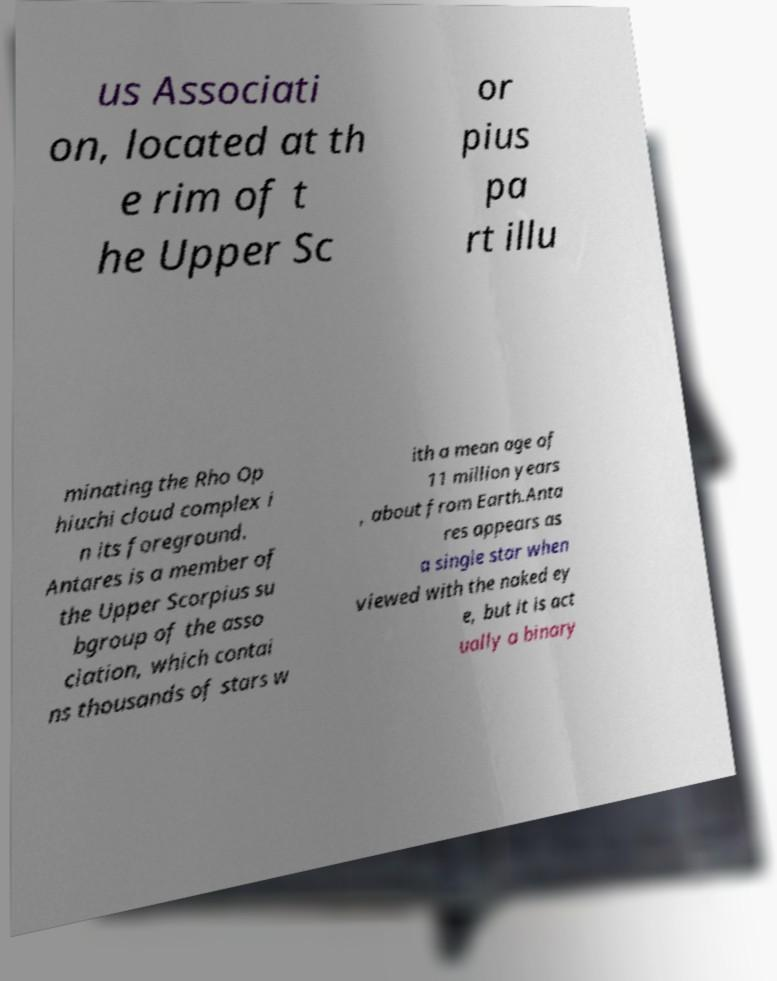Could you assist in decoding the text presented in this image and type it out clearly? us Associati on, located at th e rim of t he Upper Sc or pius pa rt illu minating the Rho Op hiuchi cloud complex i n its foreground. Antares is a member of the Upper Scorpius su bgroup of the asso ciation, which contai ns thousands of stars w ith a mean age of 11 million years , about from Earth.Anta res appears as a single star when viewed with the naked ey e, but it is act ually a binary 